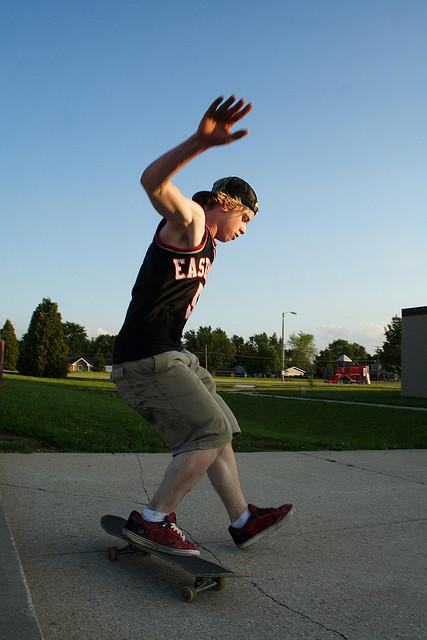How many arms does he have?
Keep it brief. 2. Is the skater's hat on forward or backward?
Quick response, please. Backward. Which foot does the male have on the skateboard?
Answer briefly. Right. Is the person in the middle of the street?
Answer briefly. No. What color are the skaters shoes?
Write a very short answer. Red. What does the shirt say?
Write a very short answer. East. Which direction is the person facing?
Write a very short answer. Right. Is the skater putting his left foot down or lifting it up?
Be succinct. Down. What is his left leg doing?
Concise answer only. Touching ground. Where is the skateboard?
Answer briefly. Ground. 